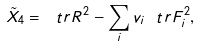<formula> <loc_0><loc_0><loc_500><loc_500>\tilde { X } _ { 4 } = \ t r R ^ { 2 } - \sum _ { i } v _ { i } \ t r F _ { i } ^ { 2 } ,</formula> 